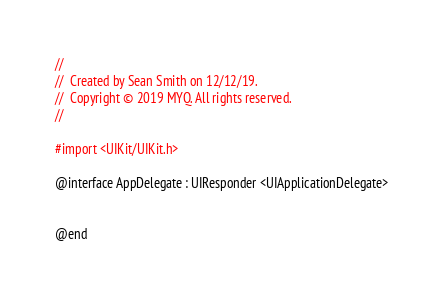<code> <loc_0><loc_0><loc_500><loc_500><_C_>//
//  Created by Sean Smith on 12/12/19.
//  Copyright © 2019 MYQ. All rights reserved.
//

#import <UIKit/UIKit.h>

@interface AppDelegate : UIResponder <UIApplicationDelegate>


@end

</code> 